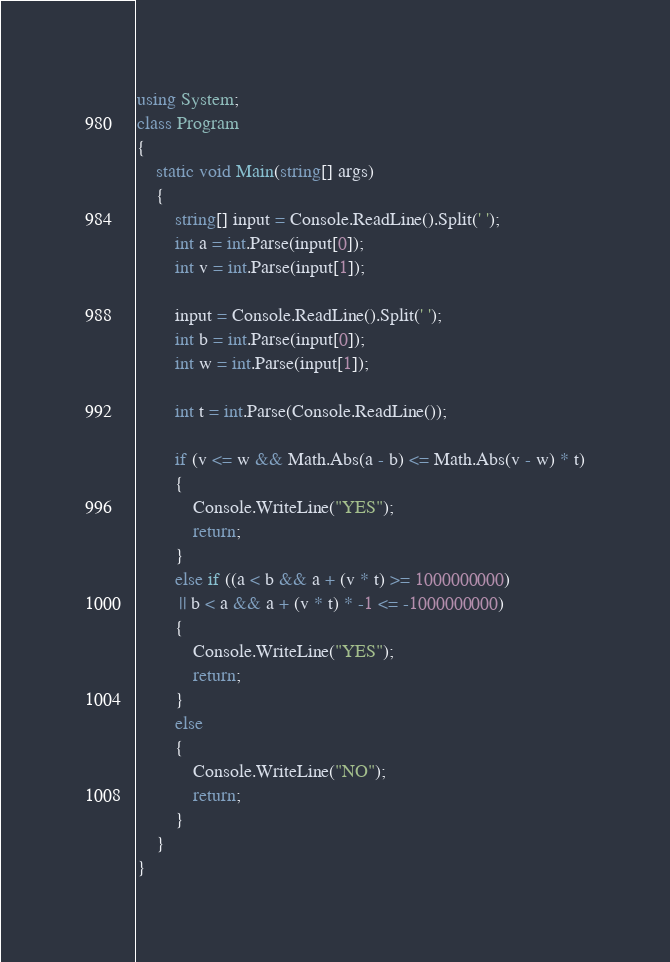<code> <loc_0><loc_0><loc_500><loc_500><_C#_>using System;
class Program
{
    static void Main(string[] args)
    {
        string[] input = Console.ReadLine().Split(' ');
        int a = int.Parse(input[0]);
        int v = int.Parse(input[1]);

        input = Console.ReadLine().Split(' ');
        int b = int.Parse(input[0]);
        int w = int.Parse(input[1]);

        int t = int.Parse(Console.ReadLine());

        if (v <= w && Math.Abs(a - b) <= Math.Abs(v - w) * t)
        {
            Console.WriteLine("YES");
            return;
        }
        else if ((a < b && a + (v * t) >= 1000000000)
         || b < a && a + (v * t) * -1 <= -1000000000)
        {
            Console.WriteLine("YES");
            return;
        }
        else
        {
            Console.WriteLine("NO");
            return;
        }
    }
}</code> 